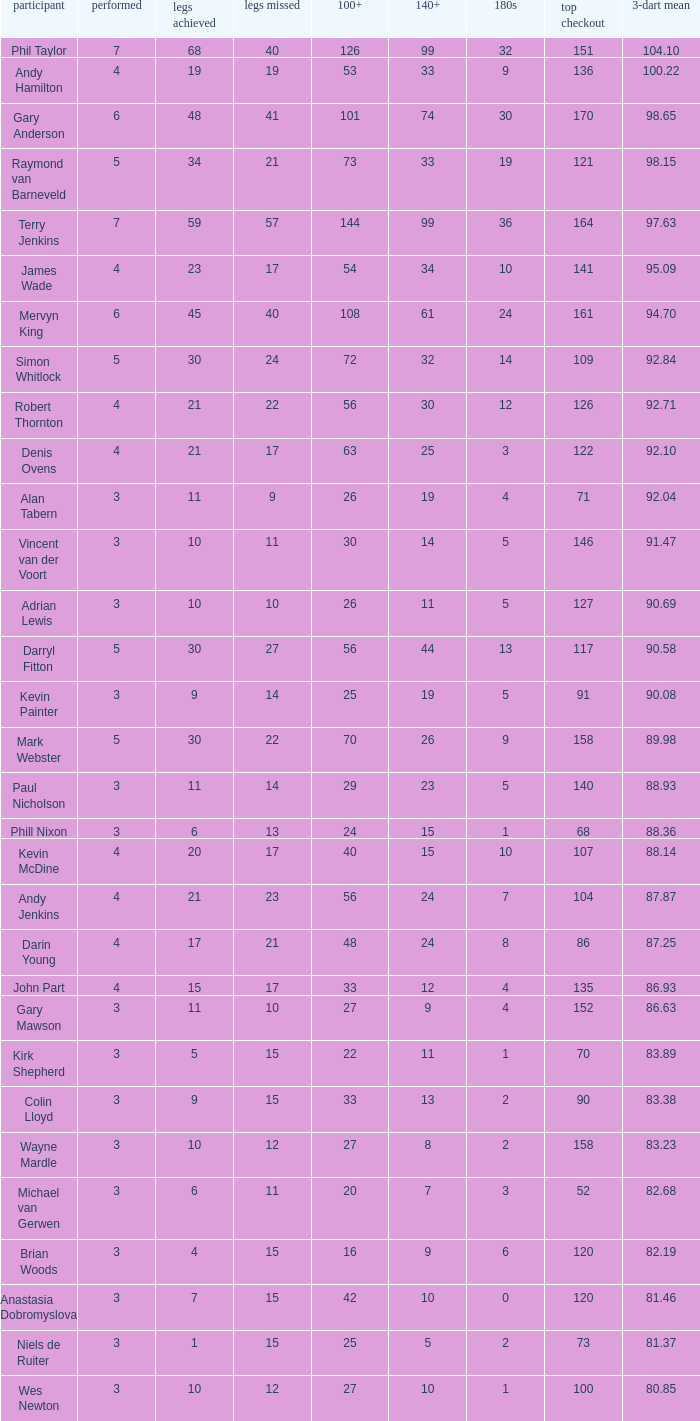I'm looking to parse the entire table for insights. Could you assist me with that? {'header': ['participant', 'performed', 'legs achieved', 'legs missed', '100+', '140+', '180s', 'top checkout', '3-dart mean'], 'rows': [['Phil Taylor', '7', '68', '40', '126', '99', '32', '151', '104.10'], ['Andy Hamilton', '4', '19', '19', '53', '33', '9', '136', '100.22'], ['Gary Anderson', '6', '48', '41', '101', '74', '30', '170', '98.65'], ['Raymond van Barneveld', '5', '34', '21', '73', '33', '19', '121', '98.15'], ['Terry Jenkins', '7', '59', '57', '144', '99', '36', '164', '97.63'], ['James Wade', '4', '23', '17', '54', '34', '10', '141', '95.09'], ['Mervyn King', '6', '45', '40', '108', '61', '24', '161', '94.70'], ['Simon Whitlock', '5', '30', '24', '72', '32', '14', '109', '92.84'], ['Robert Thornton', '4', '21', '22', '56', '30', '12', '126', '92.71'], ['Denis Ovens', '4', '21', '17', '63', '25', '3', '122', '92.10'], ['Alan Tabern', '3', '11', '9', '26', '19', '4', '71', '92.04'], ['Vincent van der Voort', '3', '10', '11', '30', '14', '5', '146', '91.47'], ['Adrian Lewis', '3', '10', '10', '26', '11', '5', '127', '90.69'], ['Darryl Fitton', '5', '30', '27', '56', '44', '13', '117', '90.58'], ['Kevin Painter', '3', '9', '14', '25', '19', '5', '91', '90.08'], ['Mark Webster', '5', '30', '22', '70', '26', '9', '158', '89.98'], ['Paul Nicholson', '3', '11', '14', '29', '23', '5', '140', '88.93'], ['Phill Nixon', '3', '6', '13', '24', '15', '1', '68', '88.36'], ['Kevin McDine', '4', '20', '17', '40', '15', '10', '107', '88.14'], ['Andy Jenkins', '4', '21', '23', '56', '24', '7', '104', '87.87'], ['Darin Young', '4', '17', '21', '48', '24', '8', '86', '87.25'], ['John Part', '4', '15', '17', '33', '12', '4', '135', '86.93'], ['Gary Mawson', '3', '11', '10', '27', '9', '4', '152', '86.63'], ['Kirk Shepherd', '3', '5', '15', '22', '11', '1', '70', '83.89'], ['Colin Lloyd', '3', '9', '15', '33', '13', '2', '90', '83.38'], ['Wayne Mardle', '3', '10', '12', '27', '8', '2', '158', '83.23'], ['Michael van Gerwen', '3', '6', '11', '20', '7', '3', '52', '82.68'], ['Brian Woods', '3', '4', '15', '16', '9', '6', '120', '82.19'], ['Anastasia Dobromyslova', '3', '7', '15', '42', '10', '0', '120', '81.46'], ['Niels de Ruiter', '3', '1', '15', '25', '5', '2', '73', '81.37'], ['Wes Newton', '3', '10', '12', '27', '10', '1', '100', '80.85']]} What is the most legs lost of all? 57.0. 